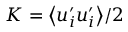<formula> <loc_0><loc_0><loc_500><loc_500>K = \Big < u _ { i } ^ { \prime } u _ { i } ^ { \prime } \Big > / 2</formula> 